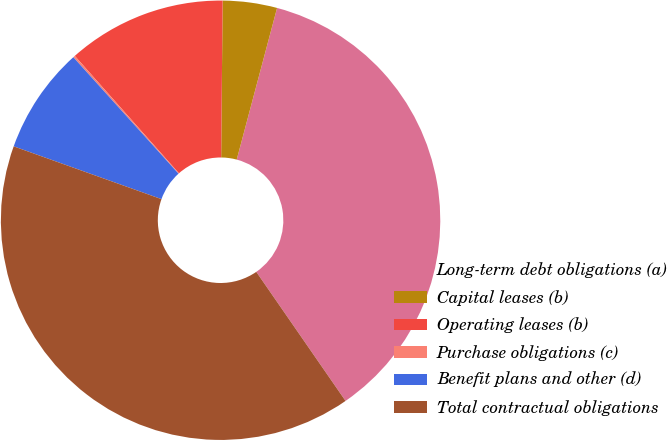Convert chart to OTSL. <chart><loc_0><loc_0><loc_500><loc_500><pie_chart><fcel>Long-term debt obligations (a)<fcel>Capital leases (b)<fcel>Operating leases (b)<fcel>Purchase obligations (c)<fcel>Benefit plans and other (d)<fcel>Total contractual obligations<nl><fcel>36.23%<fcel>3.99%<fcel>11.7%<fcel>0.14%<fcel>7.85%<fcel>40.09%<nl></chart> 